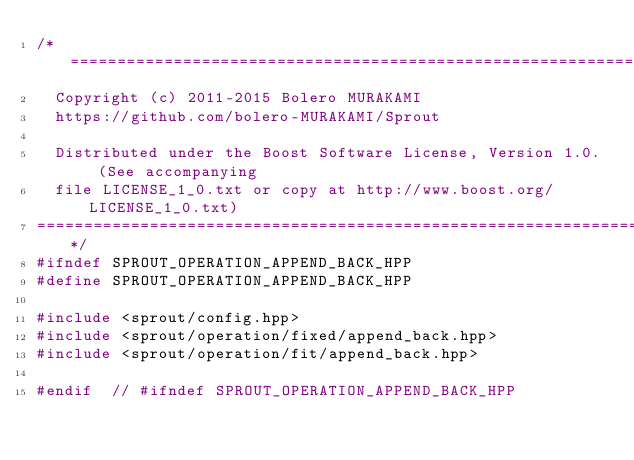<code> <loc_0><loc_0><loc_500><loc_500><_C++_>/*=============================================================================
  Copyright (c) 2011-2015 Bolero MURAKAMI
  https://github.com/bolero-MURAKAMI/Sprout

  Distributed under the Boost Software License, Version 1.0. (See accompanying
  file LICENSE_1_0.txt or copy at http://www.boost.org/LICENSE_1_0.txt)
=============================================================================*/
#ifndef SPROUT_OPERATION_APPEND_BACK_HPP
#define SPROUT_OPERATION_APPEND_BACK_HPP

#include <sprout/config.hpp>
#include <sprout/operation/fixed/append_back.hpp>
#include <sprout/operation/fit/append_back.hpp>

#endif	// #ifndef SPROUT_OPERATION_APPEND_BACK_HPP
</code> 